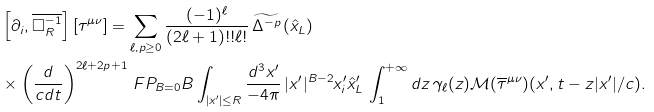<formula> <loc_0><loc_0><loc_500><loc_500>& \left [ \partial _ { i } , \overline { \Box _ { R } ^ { - 1 } } \right ] [ \tau ^ { \mu \nu } ] = \sum _ { \ell , p \geq 0 } \frac { ( - 1 ) ^ { \ell } } { ( 2 \ell + 1 ) ! ! \ell ! } \, \widetilde { \Delta ^ { - p } } \left ( \hat { x } _ { L } \right ) \\ & \times \left ( \frac { d } { c d t } \right ) ^ { 2 \ell + 2 p + 1 } \, F P _ { B = 0 } B \int _ { | x ^ { \prime } | \leq R } \frac { d ^ { 3 } x ^ { \prime } } { - 4 \pi } \, | x ^ { \prime } | ^ { B - 2 } x ^ { \prime } _ { i } \hat { x } ^ { \prime } _ { L } \, \int _ { 1 } ^ { + \infty } d z \, \gamma _ { \ell } ( z ) \mathcal { M } ( \overline { \tau } ^ { \mu \nu } ) ( x ^ { \prime } , t - z | x ^ { \prime } | / c ) .</formula> 